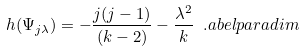<formula> <loc_0><loc_0><loc_500><loc_500>h ( \Psi _ { j \lambda } ) = - \frac { j ( j - 1 ) } { ( k - 2 ) } - \frac { \lambda ^ { 2 } } { k } \ . \L a b e l { p a r a d i m }</formula> 